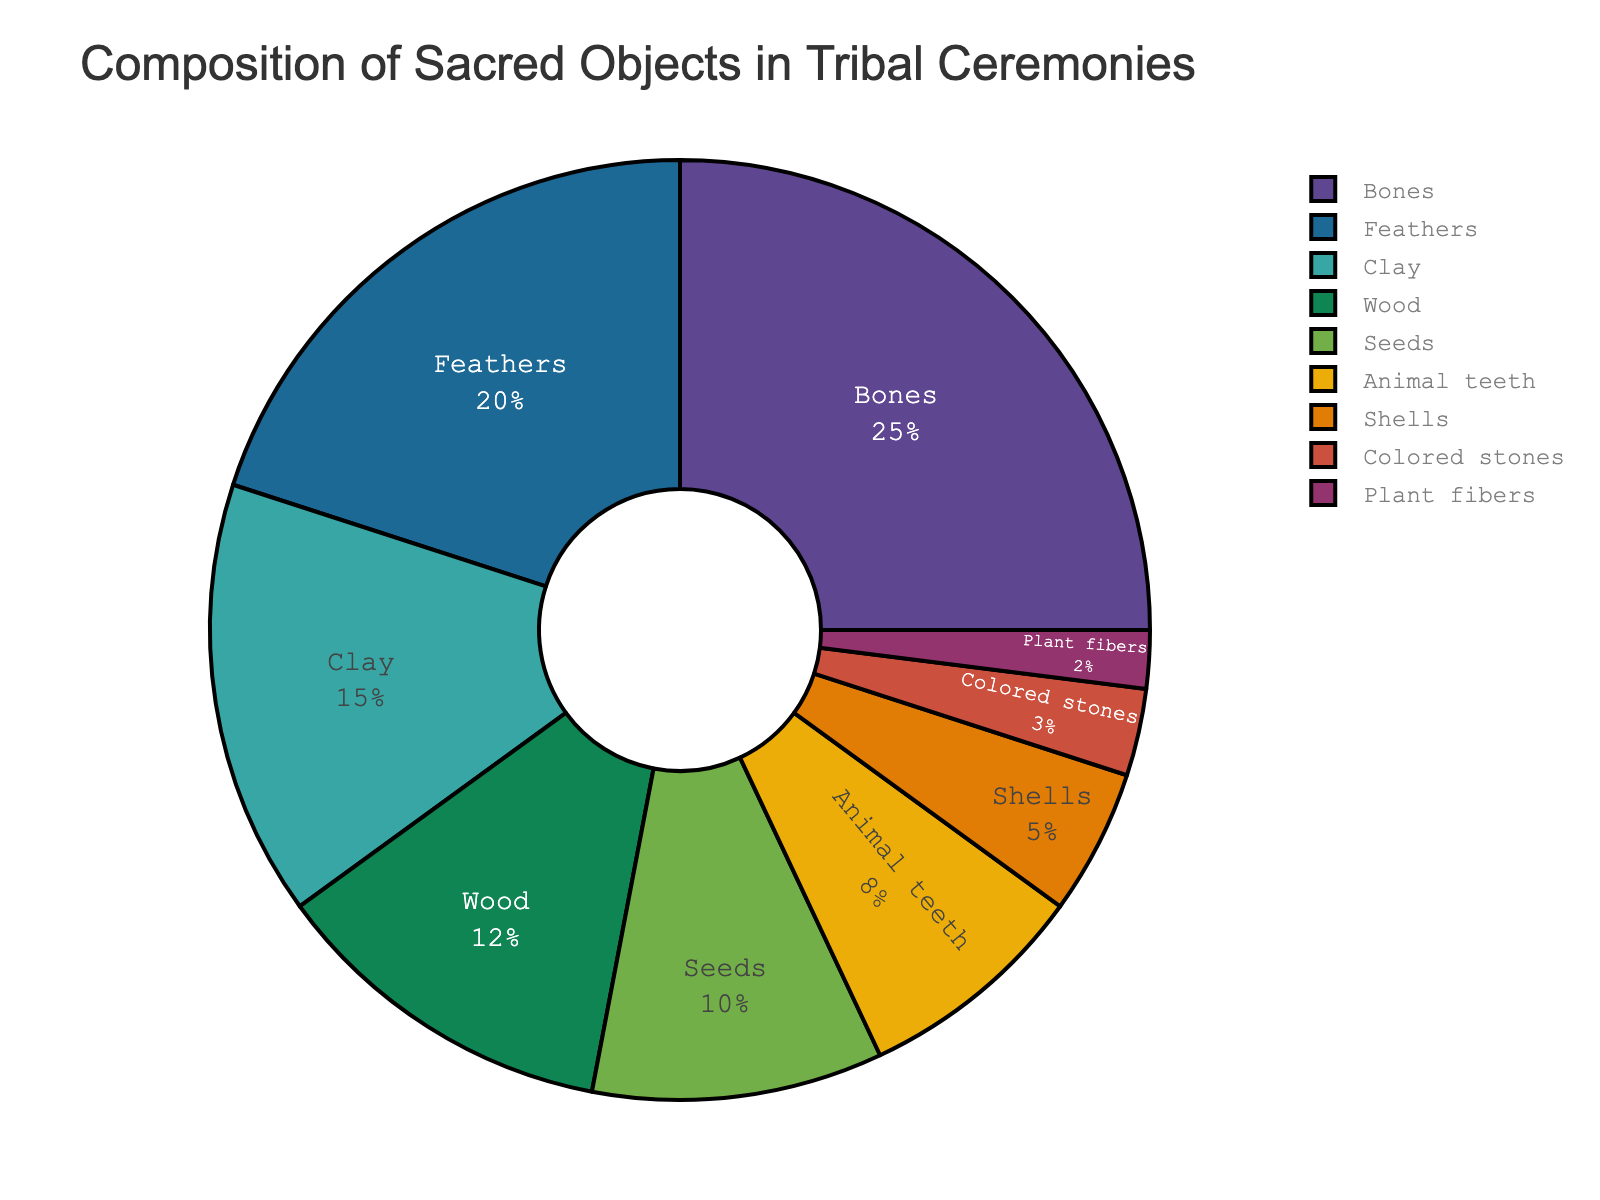What material is used most frequently in tribal ceremonies? The pie chart shows the percentage composition of different sacred materials. The largest segment represents Bones with 25%.
Answer: Bones Which material is used less frequently, shells or wood? By comparing the percentages on the pie chart, Shells have 5% while Wood has 12%.
Answer: Shells What is the combined percentage of Bones and Feathers? To find the combined percentage, sum the given values for Bones (25%) and Feathers (20%). The total is 45%.
Answer: 45% How many more times is Clay used compared to Shells? Clay is 15% while Shells are 5%. The ratio of Clay to Shells is 15/5, which simplifies to 3 times.
Answer: 3 times What is the difference in percentage between the use of Feathers and Seeds? Subtract the percentage of Seeds (10%) from the percentage of Feathers (20%) to find the difference: 20% - 10% = 10%.
Answer: 10% In terms of ceremonial object usage, is Animal teeth more commonly used than Clay? By comparing the pie chart percentages, Animal teeth have 8% and Clay has 15%. Therefore, Clay is used more commonly than Animal teeth.
Answer: No Which materials have a combined percentage lower than that of Bones? Combine the percentages of Clay (15%), Wood (12%), Seeds (10%), Animal teeth (8%), Shells (5%), Colored stones (3%), and Plant fibers (2%). The sum is 55%. Each material individually (except Feathers) is also less than 25%.
Answer: All materials except Feathers Which materials are represented by segments of blue shades? Examine the pie chart's legend and correspond colored segments for Feathers, Clay, Seeds, and Shells showing slight variations of blue.
Answer: Feathers, Clay, Seeds, Shells What is the sum of all materials that have a percentage less than 10%? Sum the percentages: Animal teeth (8%), Shells (5%), Colored stones (3%), and Plant fibers (2%). This gives 8% + 5% + 3% + 2% = 18%.
Answer: 18% If the colored stones' percentage doubled, would it be larger than Wood's percentage? Doubling Colored stones' percentage from 3% results in 3% * 2 = 6%. This is still less than Wood's 12%.
Answer: No 